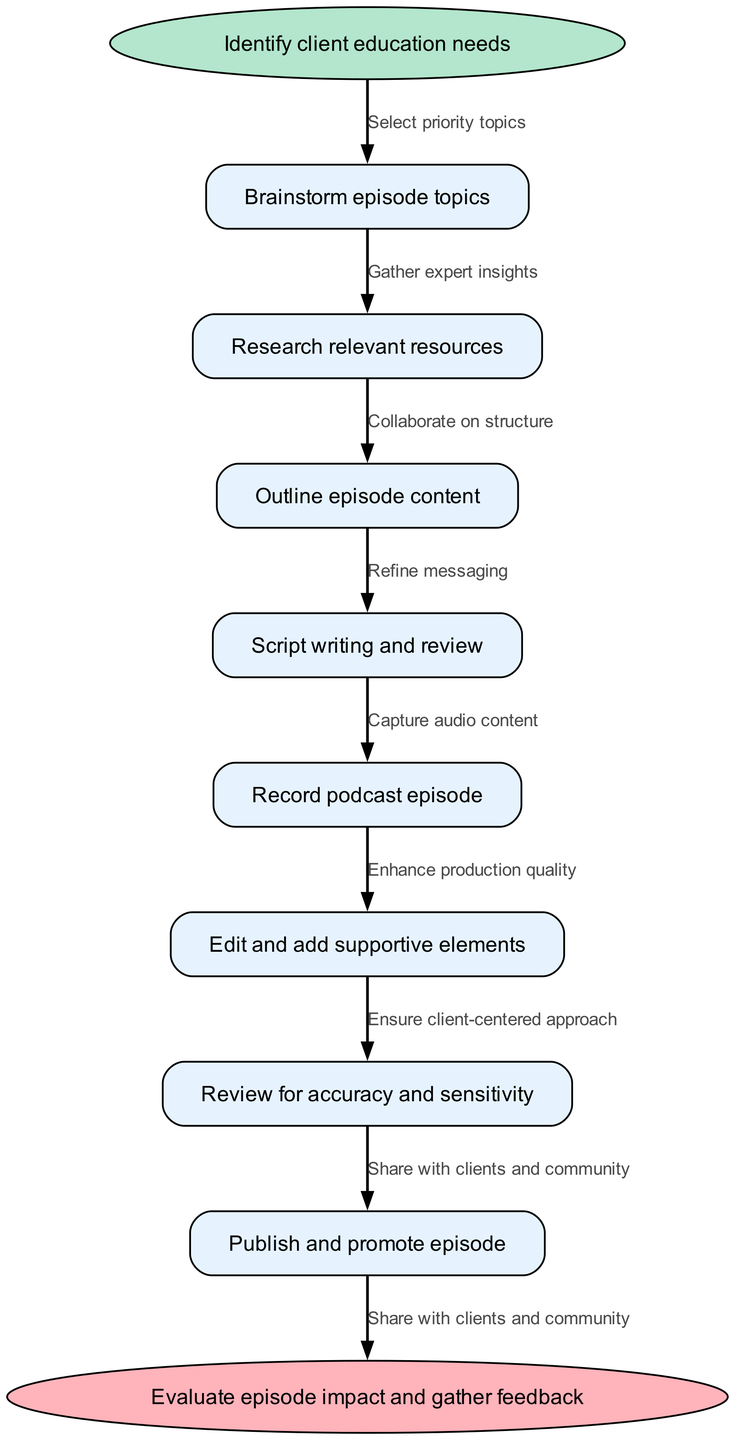What is the starting point of the process? The starting point of the process is labeled as "Identify client education needs." This is clearly indicated as the first node in the diagram.
Answer: Identify client education needs How many main process nodes are there in the diagram? By counting the specific nodes listed in the diagram, we find there are eight main process nodes. Each node represents a distinct step in the podcast episode planning.
Answer: 8 What is the last step before evaluating the episode impact? The last step before the evaluation is "Publish and promote episode," which is the second-to-last node leading to the final evaluation stage.
Answer: Publish and promote episode Which node directly follows "Brainstorm episode topics"? The node that directly follows "Brainstorm episode topics" is "Research relevant resources," as the edges connect these two nodes in sequence.
Answer: Research relevant resources What is the purpose of reviewing for accuracy and sensitivity? The purpose of this step, indicated in the diagram, is to ensure the content is precise and considers the client's needs respectfully.
Answer: Ensure client-centered approach How many edges connect the start node to the end node? There are eight edges in total connecting the start node to the end node, as each edge represents a transition from one step in the process to the next until reaching the evaluation phase.
Answer: 8 What action is taken after recording the podcast episode? After recording the podcast episode, the next action is "Edit and add supportive elements," which focuses on improving the quality and effectiveness of the content.
Answer: Edit and add supportive elements What is the focus of the "Outline episode content"? The focus of this step is to create a structured plan for the podcast episode, detailing the major topics to cover and the flow of the discussion.
Answer: Major topics to cover Which step involves gathering expert insights? The step labeled "Research relevant resources" involves gathering expert insights as part of the preparation for the podcast content.
Answer: Research relevant resources 